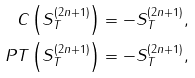<formula> <loc_0><loc_0><loc_500><loc_500>C \left ( S _ { T } ^ { \left ( 2 n + 1 \right ) } \right ) & = - S _ { T } ^ { \left ( 2 n + 1 \right ) } , \\ P T \left ( S _ { T } ^ { \left ( 2 n + 1 \right ) } \right ) & = - S _ { T } ^ { \left ( 2 n + 1 \right ) } ,</formula> 